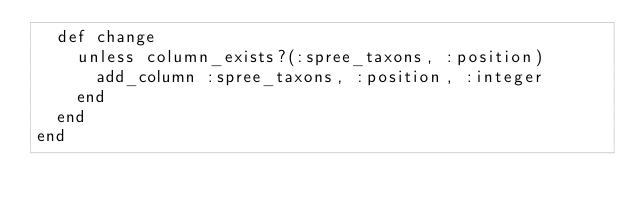<code> <loc_0><loc_0><loc_500><loc_500><_Ruby_>  def change
    unless column_exists?(:spree_taxons, :position)
      add_column :spree_taxons, :position, :integer
    end
  end
end
</code> 